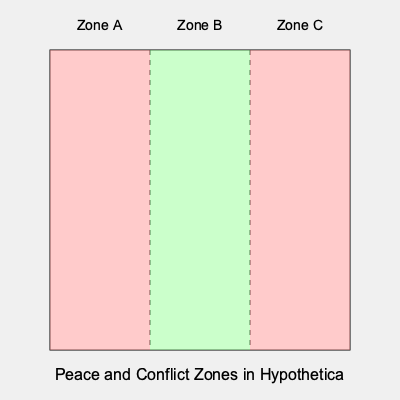Based on the map of Hypothetica showing peace and conflict zones, what percentage of the country's area is currently in a state of peace, and how might this information be crucial for planning humanitarian aid distribution? To answer this question, we need to analyze the map and calculate the percentage of peaceful areas:

1. The map is divided into three equal zones: A, B, and C.
2. Zone B (the middle section) is colored green, indicating a peaceful area.
3. Zones A and C (the outer sections) are colored red, indicating conflict areas.
4. Since the zones are equal in size, we can calculate the percentage of peaceful area:
   - Total zones: 3
   - Peaceful zones: 1
   - Percentage calculation: $(1 / 3) \times 100\% = 33.33\%$

5. This information is crucial for planning humanitarian aid distribution because:
   - Aid can be more easily distributed in peaceful areas (Zone B).
   - Zone B can serve as a base for operations and storage of supplies.
   - Access to conflict zones (A and C) may require special security measures or negotiations.
   - The peaceful zone might experience an influx of internally displaced persons from conflict areas, increasing the need for resources there.
   - Aid organizations can prioritize resources based on the relative sizes of peace and conflict zones.

6. As a peace activist with military experience, you would understand the importance of safe access routes and the challenges of operating in conflict zones, making this information vital for effective aid planning and distribution.
Answer: 33.33% of the country is peaceful; crucial for safe aid distribution, resource allocation, and operation planning. 